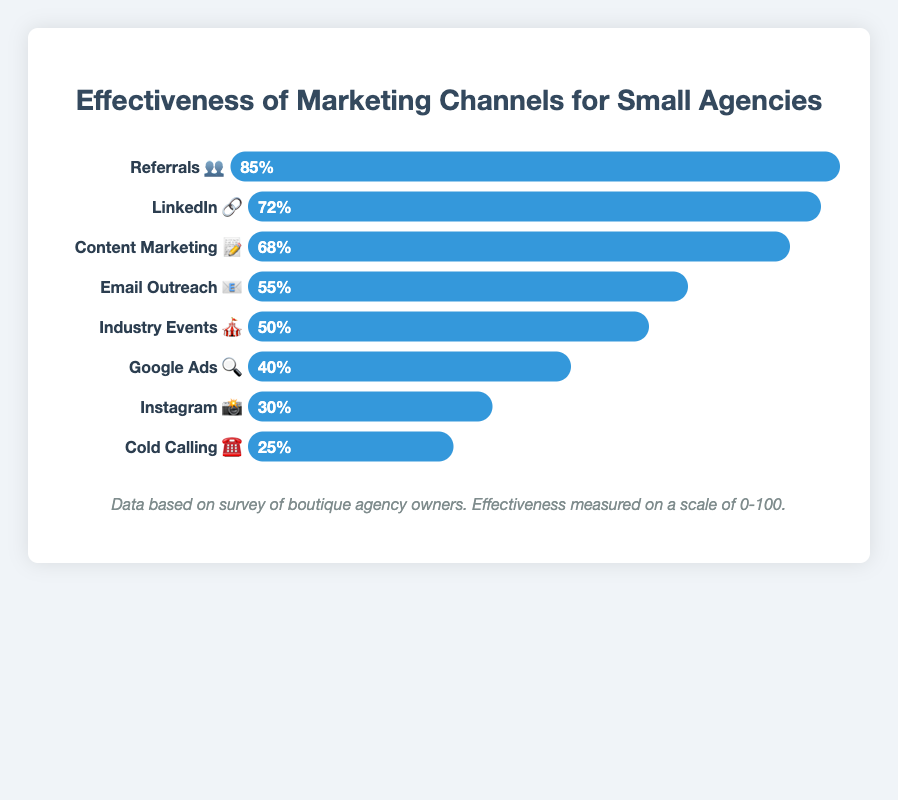Which marketing channel is shown to be the most effective? Referrals have the highest effectiveness measurement. Referrals 👥 have an effectiveness score of 85.
Answer: Referrals 👥 What is the least effective marketing channel according to the figure? The marketing channel with the lowest effectiveness score is Cold Calling ☎️, which has a score of 25.
Answer: Cold Calling ☎️ How does LinkedIn compare to Email Outreach in terms of effectiveness? LinkedIn 🔗 has an effectiveness score of 72, while Email Outreach 📧 has a score of 55. Comparatively, LinkedIn is more effective.
Answer: LinkedIn 🔗 is more effective Which channels have an effectiveness score of 50 or below? The channels with scores of 50 or below are Industry Events 🎪 (50), Google Ads 🔍 (40), Instagram 📸 (30), and Cold Calling ☎️ (25).
Answer: Industry Events 🎪, Google Ads 🔍, Instagram 📸, Cold Calling ☎️ What channels have an effectiveness score above 60? Channels with scores greater than 60 are Referrals 👥 (85), LinkedIn 🔗 (72), and Content Marketing 📝 (68).
Answer: Referrals 👥, LinkedIn 🔗, Content Marketing 📝 How much more effective is Content Marketing compared to Google Ads? Content Marketing 📝 has an effectiveness score of 68, while Google Ads 🔍 has a score of 40. The difference in effectiveness is 68 - 40 = 28.
Answer: 28 Rank the marketing channels from least effective to most effective. The channels in increasing order of effectiveness are Cold Calling ☎️ (25), Instagram 📸 (30), Google Ads 🔍 (40), Industry Events 🎪 (50), Email Outreach 📧 (55), Content Marketing 📝 (68), LinkedIn 🔗 (72), and Referrals 👥 (85).
Answer: Cold Calling ☎️, Instagram 📸, Google Ads 🔍, Industry Events 🎪, Email Outreach 📧, Content Marketing 📝, LinkedIn 🔗, Referrals 👥 What is the average effectiveness score of all the listed marketing channels? Sum the effectiveness scores: 85 + 72 + 68 + 55 + 50 + 40 + 30 + 25 = 425. Divide by the number of channels, which is 8. The average is 425 / 8 = 53.125.
Answer: 53.125 